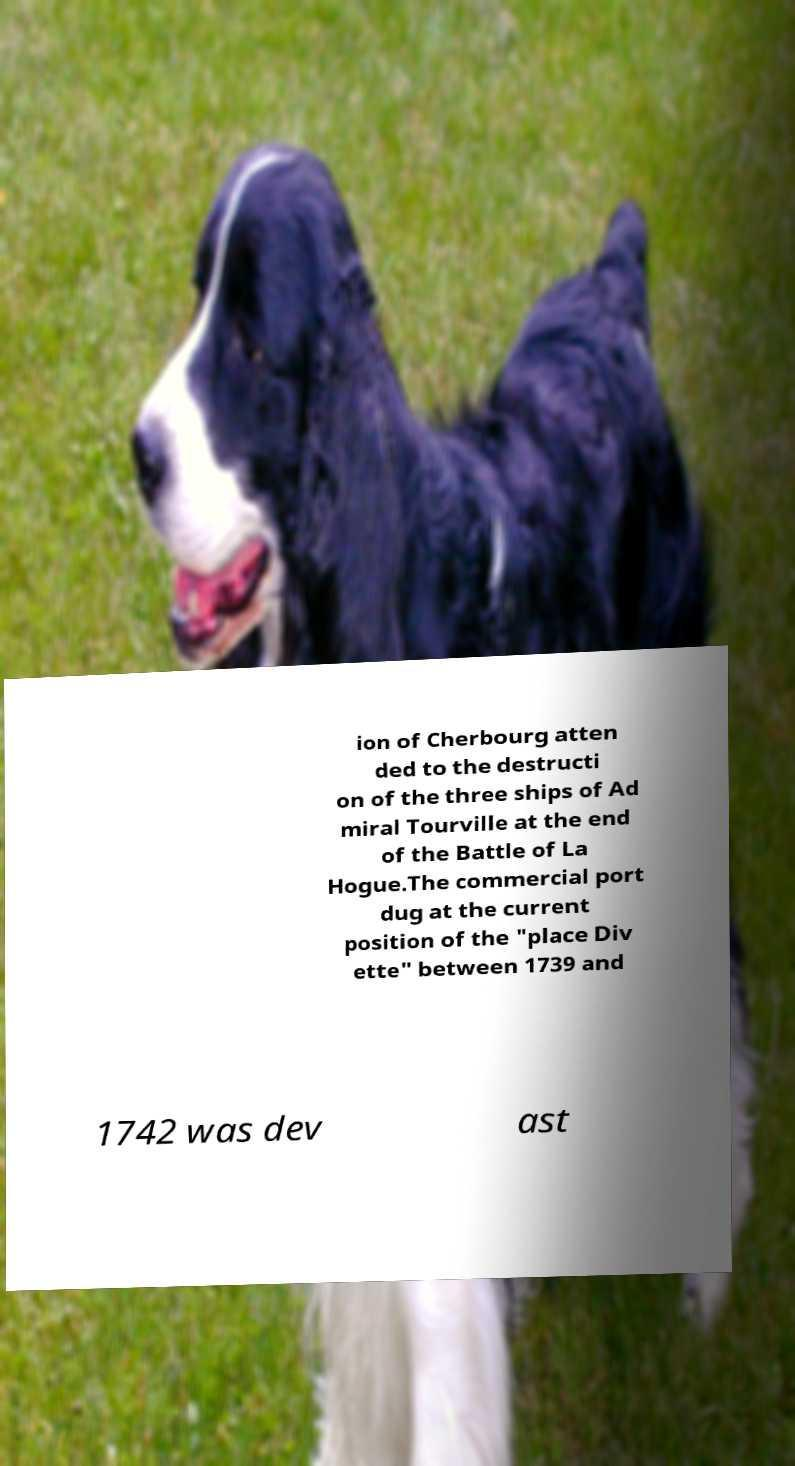For documentation purposes, I need the text within this image transcribed. Could you provide that? ion of Cherbourg atten ded to the destructi on of the three ships of Ad miral Tourville at the end of the Battle of La Hogue.The commercial port dug at the current position of the "place Div ette" between 1739 and 1742 was dev ast 